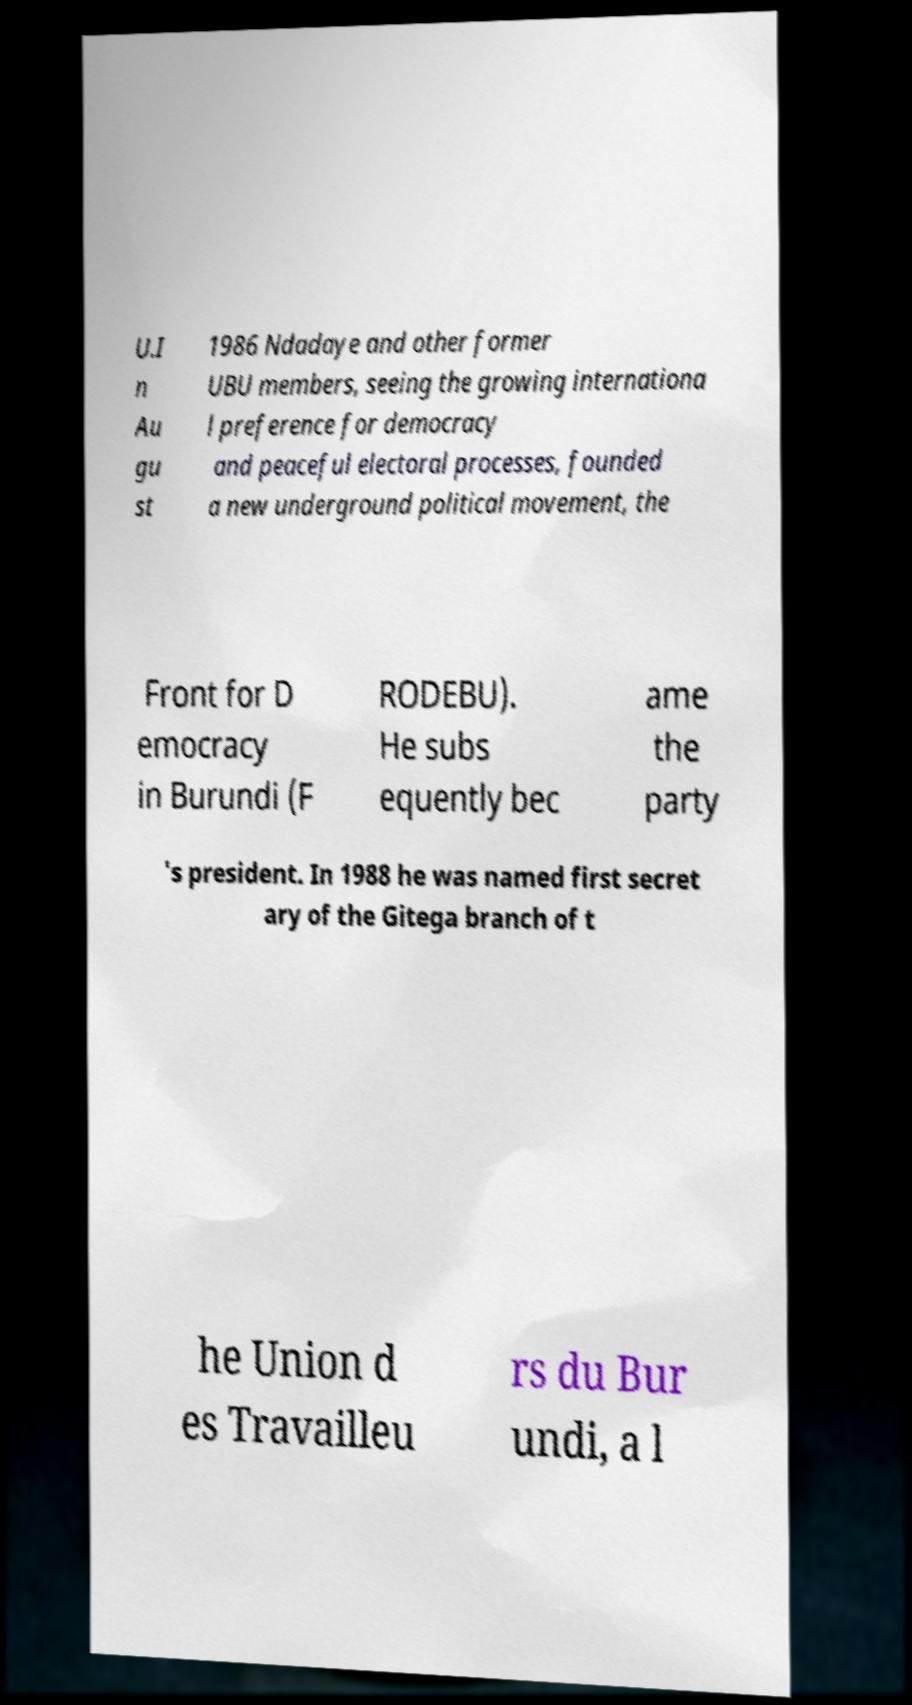What messages or text are displayed in this image? I need them in a readable, typed format. U.I n Au gu st 1986 Ndadaye and other former UBU members, seeing the growing internationa l preference for democracy and peaceful electoral processes, founded a new underground political movement, the Front for D emocracy in Burundi (F RODEBU). He subs equently bec ame the party 's president. In 1988 he was named first secret ary of the Gitega branch of t he Union d es Travailleu rs du Bur undi, a l 